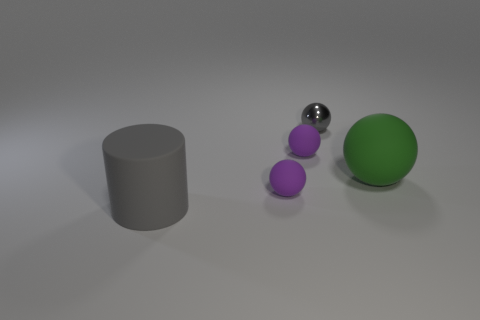There is a large rubber object behind the large gray thing; is its shape the same as the big rubber object on the left side of the small gray shiny thing?
Offer a terse response. No. Are there any purple things made of the same material as the small gray ball?
Your answer should be very brief. No. How many yellow things are either shiny things or rubber balls?
Give a very brief answer. 0. There is a ball that is in front of the tiny gray metallic sphere and behind the large green rubber sphere; what is its size?
Your answer should be very brief. Small. Are there more things that are in front of the gray metallic sphere than small gray matte balls?
Your response must be concise. Yes. How many cubes are either big objects or large gray things?
Your answer should be very brief. 0. The thing that is both in front of the large green ball and to the right of the big rubber cylinder has what shape?
Give a very brief answer. Sphere. Is the number of green rubber balls that are to the left of the gray metallic ball the same as the number of big green objects left of the big ball?
Your answer should be compact. Yes. How many things are big rubber spheres or brown rubber cylinders?
Keep it short and to the point. 1. There is a cylinder that is the same size as the green rubber ball; what is its color?
Provide a succinct answer. Gray. 